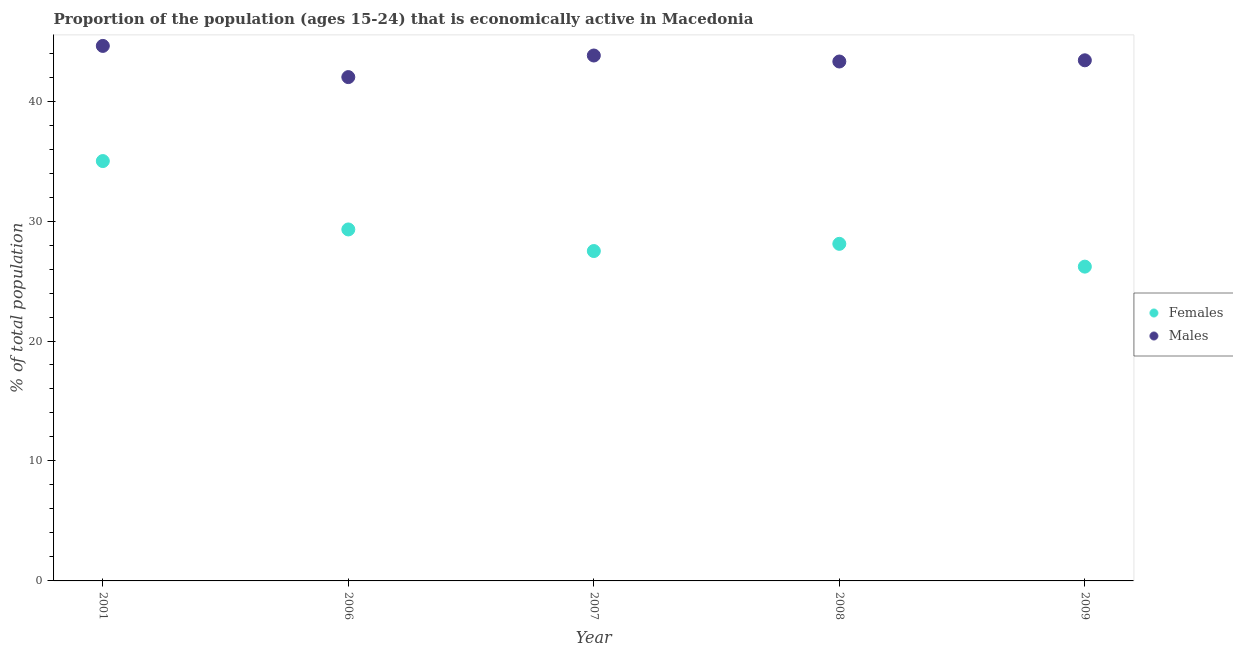Is the number of dotlines equal to the number of legend labels?
Ensure brevity in your answer.  Yes. What is the percentage of economically active male population in 2006?
Make the answer very short. 42. Across all years, what is the maximum percentage of economically active male population?
Ensure brevity in your answer.  44.6. In which year was the percentage of economically active female population minimum?
Offer a very short reply. 2009. What is the total percentage of economically active male population in the graph?
Ensure brevity in your answer.  217.1. What is the difference between the percentage of economically active male population in 2001 and that in 2007?
Your answer should be compact. 0.8. What is the average percentage of economically active male population per year?
Ensure brevity in your answer.  43.42. In the year 2008, what is the difference between the percentage of economically active female population and percentage of economically active male population?
Ensure brevity in your answer.  -15.2. What is the ratio of the percentage of economically active male population in 2006 to that in 2008?
Give a very brief answer. 0.97. Is the percentage of economically active male population in 2007 less than that in 2008?
Your answer should be compact. No. What is the difference between the highest and the second highest percentage of economically active male population?
Your answer should be very brief. 0.8. What is the difference between the highest and the lowest percentage of economically active female population?
Offer a terse response. 8.8. How many dotlines are there?
Offer a very short reply. 2. How many years are there in the graph?
Ensure brevity in your answer.  5. Does the graph contain any zero values?
Offer a very short reply. No. Does the graph contain grids?
Provide a succinct answer. No. Where does the legend appear in the graph?
Your response must be concise. Center right. What is the title of the graph?
Provide a short and direct response. Proportion of the population (ages 15-24) that is economically active in Macedonia. What is the label or title of the X-axis?
Provide a succinct answer. Year. What is the label or title of the Y-axis?
Offer a very short reply. % of total population. What is the % of total population in Males in 2001?
Offer a very short reply. 44.6. What is the % of total population of Females in 2006?
Provide a short and direct response. 29.3. What is the % of total population in Females in 2007?
Give a very brief answer. 27.5. What is the % of total population of Males in 2007?
Provide a succinct answer. 43.8. What is the % of total population of Females in 2008?
Your response must be concise. 28.1. What is the % of total population in Males in 2008?
Provide a short and direct response. 43.3. What is the % of total population of Females in 2009?
Offer a very short reply. 26.2. What is the % of total population in Males in 2009?
Offer a very short reply. 43.4. Across all years, what is the maximum % of total population in Females?
Provide a succinct answer. 35. Across all years, what is the maximum % of total population of Males?
Make the answer very short. 44.6. Across all years, what is the minimum % of total population of Females?
Keep it short and to the point. 26.2. Across all years, what is the minimum % of total population in Males?
Give a very brief answer. 42. What is the total % of total population of Females in the graph?
Provide a succinct answer. 146.1. What is the total % of total population in Males in the graph?
Your response must be concise. 217.1. What is the difference between the % of total population of Females in 2001 and that in 2006?
Give a very brief answer. 5.7. What is the difference between the % of total population in Males in 2001 and that in 2006?
Give a very brief answer. 2.6. What is the difference between the % of total population in Females in 2001 and that in 2007?
Provide a succinct answer. 7.5. What is the difference between the % of total population of Males in 2001 and that in 2007?
Your answer should be compact. 0.8. What is the difference between the % of total population in Males in 2001 and that in 2008?
Keep it short and to the point. 1.3. What is the difference between the % of total population of Females in 2001 and that in 2009?
Ensure brevity in your answer.  8.8. What is the difference between the % of total population of Males in 2006 and that in 2007?
Offer a very short reply. -1.8. What is the difference between the % of total population of Males in 2006 and that in 2008?
Your answer should be compact. -1.3. What is the difference between the % of total population of Females in 2007 and that in 2009?
Your answer should be compact. 1.3. What is the difference between the % of total population of Females in 2008 and that in 2009?
Ensure brevity in your answer.  1.9. What is the difference between the % of total population of Females in 2001 and the % of total population of Males in 2006?
Offer a very short reply. -7. What is the difference between the % of total population of Females in 2001 and the % of total population of Males in 2008?
Ensure brevity in your answer.  -8.3. What is the difference between the % of total population in Females in 2001 and the % of total population in Males in 2009?
Your answer should be very brief. -8.4. What is the difference between the % of total population in Females in 2006 and the % of total population in Males in 2007?
Provide a short and direct response. -14.5. What is the difference between the % of total population in Females in 2006 and the % of total population in Males in 2008?
Keep it short and to the point. -14. What is the difference between the % of total population of Females in 2006 and the % of total population of Males in 2009?
Give a very brief answer. -14.1. What is the difference between the % of total population in Females in 2007 and the % of total population in Males in 2008?
Provide a short and direct response. -15.8. What is the difference between the % of total population in Females in 2007 and the % of total population in Males in 2009?
Give a very brief answer. -15.9. What is the difference between the % of total population of Females in 2008 and the % of total population of Males in 2009?
Offer a very short reply. -15.3. What is the average % of total population in Females per year?
Keep it short and to the point. 29.22. What is the average % of total population in Males per year?
Offer a very short reply. 43.42. In the year 2001, what is the difference between the % of total population in Females and % of total population in Males?
Keep it short and to the point. -9.6. In the year 2007, what is the difference between the % of total population in Females and % of total population in Males?
Offer a very short reply. -16.3. In the year 2008, what is the difference between the % of total population in Females and % of total population in Males?
Provide a succinct answer. -15.2. In the year 2009, what is the difference between the % of total population in Females and % of total population in Males?
Provide a short and direct response. -17.2. What is the ratio of the % of total population in Females in 2001 to that in 2006?
Provide a short and direct response. 1.19. What is the ratio of the % of total population in Males in 2001 to that in 2006?
Provide a succinct answer. 1.06. What is the ratio of the % of total population in Females in 2001 to that in 2007?
Keep it short and to the point. 1.27. What is the ratio of the % of total population of Males in 2001 to that in 2007?
Give a very brief answer. 1.02. What is the ratio of the % of total population in Females in 2001 to that in 2008?
Your answer should be very brief. 1.25. What is the ratio of the % of total population of Males in 2001 to that in 2008?
Make the answer very short. 1.03. What is the ratio of the % of total population of Females in 2001 to that in 2009?
Your answer should be compact. 1.34. What is the ratio of the % of total population in Males in 2001 to that in 2009?
Give a very brief answer. 1.03. What is the ratio of the % of total population of Females in 2006 to that in 2007?
Keep it short and to the point. 1.07. What is the ratio of the % of total population in Males in 2006 to that in 2007?
Keep it short and to the point. 0.96. What is the ratio of the % of total population in Females in 2006 to that in 2008?
Give a very brief answer. 1.04. What is the ratio of the % of total population in Males in 2006 to that in 2008?
Offer a very short reply. 0.97. What is the ratio of the % of total population in Females in 2006 to that in 2009?
Your answer should be very brief. 1.12. What is the ratio of the % of total population of Males in 2006 to that in 2009?
Ensure brevity in your answer.  0.97. What is the ratio of the % of total population in Females in 2007 to that in 2008?
Your response must be concise. 0.98. What is the ratio of the % of total population in Males in 2007 to that in 2008?
Your answer should be very brief. 1.01. What is the ratio of the % of total population in Females in 2007 to that in 2009?
Your answer should be compact. 1.05. What is the ratio of the % of total population in Males in 2007 to that in 2009?
Give a very brief answer. 1.01. What is the ratio of the % of total population of Females in 2008 to that in 2009?
Provide a short and direct response. 1.07. What is the difference between the highest and the lowest % of total population of Females?
Your response must be concise. 8.8. 